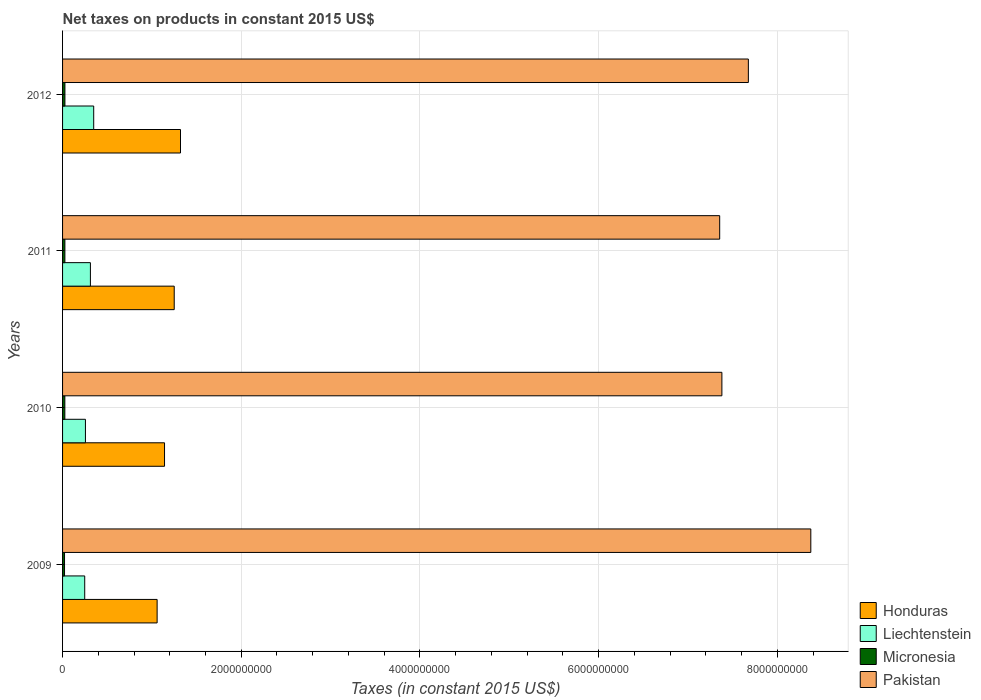How many different coloured bars are there?
Keep it short and to the point. 4. How many groups of bars are there?
Your response must be concise. 4. Are the number of bars on each tick of the Y-axis equal?
Provide a short and direct response. Yes. How many bars are there on the 3rd tick from the bottom?
Offer a very short reply. 4. What is the net taxes on products in Micronesia in 2012?
Offer a very short reply. 2.63e+07. Across all years, what is the maximum net taxes on products in Pakistan?
Make the answer very short. 8.38e+09. Across all years, what is the minimum net taxes on products in Micronesia?
Offer a very short reply. 2.20e+07. In which year was the net taxes on products in Liechtenstein maximum?
Your response must be concise. 2012. What is the total net taxes on products in Micronesia in the graph?
Offer a very short reply. 9.98e+07. What is the difference between the net taxes on products in Liechtenstein in 2009 and that in 2010?
Provide a succinct answer. -7.97e+06. What is the difference between the net taxes on products in Micronesia in 2009 and the net taxes on products in Honduras in 2012?
Your answer should be compact. -1.30e+09. What is the average net taxes on products in Micronesia per year?
Ensure brevity in your answer.  2.49e+07. In the year 2010, what is the difference between the net taxes on products in Honduras and net taxes on products in Micronesia?
Offer a very short reply. 1.12e+09. In how many years, is the net taxes on products in Liechtenstein greater than 3600000000 US$?
Make the answer very short. 0. What is the ratio of the net taxes on products in Liechtenstein in 2009 to that in 2012?
Give a very brief answer. 0.71. What is the difference between the highest and the second highest net taxes on products in Micronesia?
Keep it short and to the point. 2.83e+05. What is the difference between the highest and the lowest net taxes on products in Honduras?
Provide a short and direct response. 2.62e+08. What does the 4th bar from the top in 2009 represents?
Keep it short and to the point. Honduras. What does the 2nd bar from the bottom in 2010 represents?
Offer a very short reply. Liechtenstein. Is it the case that in every year, the sum of the net taxes on products in Pakistan and net taxes on products in Liechtenstein is greater than the net taxes on products in Honduras?
Give a very brief answer. Yes. How many bars are there?
Give a very brief answer. 16. Does the graph contain any zero values?
Offer a terse response. No. Does the graph contain grids?
Provide a short and direct response. Yes. Where does the legend appear in the graph?
Your answer should be very brief. Bottom right. How are the legend labels stacked?
Your response must be concise. Vertical. What is the title of the graph?
Give a very brief answer. Net taxes on products in constant 2015 US$. What is the label or title of the X-axis?
Offer a terse response. Taxes (in constant 2015 US$). What is the label or title of the Y-axis?
Offer a terse response. Years. What is the Taxes (in constant 2015 US$) in Honduras in 2009?
Provide a succinct answer. 1.06e+09. What is the Taxes (in constant 2015 US$) in Liechtenstein in 2009?
Your response must be concise. 2.48e+08. What is the Taxes (in constant 2015 US$) in Micronesia in 2009?
Your answer should be very brief. 2.20e+07. What is the Taxes (in constant 2015 US$) of Pakistan in 2009?
Provide a succinct answer. 8.38e+09. What is the Taxes (in constant 2015 US$) of Honduras in 2010?
Offer a terse response. 1.14e+09. What is the Taxes (in constant 2015 US$) of Liechtenstein in 2010?
Provide a succinct answer. 2.56e+08. What is the Taxes (in constant 2015 US$) of Micronesia in 2010?
Your answer should be very brief. 2.54e+07. What is the Taxes (in constant 2015 US$) of Pakistan in 2010?
Ensure brevity in your answer.  7.38e+09. What is the Taxes (in constant 2015 US$) in Honduras in 2011?
Provide a succinct answer. 1.25e+09. What is the Taxes (in constant 2015 US$) in Liechtenstein in 2011?
Keep it short and to the point. 3.12e+08. What is the Taxes (in constant 2015 US$) in Micronesia in 2011?
Keep it short and to the point. 2.60e+07. What is the Taxes (in constant 2015 US$) of Pakistan in 2011?
Give a very brief answer. 7.36e+09. What is the Taxes (in constant 2015 US$) of Honduras in 2012?
Ensure brevity in your answer.  1.32e+09. What is the Taxes (in constant 2015 US$) of Liechtenstein in 2012?
Give a very brief answer. 3.49e+08. What is the Taxes (in constant 2015 US$) in Micronesia in 2012?
Your answer should be very brief. 2.63e+07. What is the Taxes (in constant 2015 US$) in Pakistan in 2012?
Provide a short and direct response. 7.68e+09. Across all years, what is the maximum Taxes (in constant 2015 US$) of Honduras?
Offer a very short reply. 1.32e+09. Across all years, what is the maximum Taxes (in constant 2015 US$) of Liechtenstein?
Your answer should be very brief. 3.49e+08. Across all years, what is the maximum Taxes (in constant 2015 US$) of Micronesia?
Make the answer very short. 2.63e+07. Across all years, what is the maximum Taxes (in constant 2015 US$) of Pakistan?
Give a very brief answer. 8.38e+09. Across all years, what is the minimum Taxes (in constant 2015 US$) in Honduras?
Keep it short and to the point. 1.06e+09. Across all years, what is the minimum Taxes (in constant 2015 US$) of Liechtenstein?
Your answer should be compact. 2.48e+08. Across all years, what is the minimum Taxes (in constant 2015 US$) of Micronesia?
Keep it short and to the point. 2.20e+07. Across all years, what is the minimum Taxes (in constant 2015 US$) in Pakistan?
Provide a succinct answer. 7.36e+09. What is the total Taxes (in constant 2015 US$) of Honduras in the graph?
Your response must be concise. 4.77e+09. What is the total Taxes (in constant 2015 US$) in Liechtenstein in the graph?
Provide a succinct answer. 1.16e+09. What is the total Taxes (in constant 2015 US$) of Micronesia in the graph?
Offer a terse response. 9.98e+07. What is the total Taxes (in constant 2015 US$) in Pakistan in the graph?
Your response must be concise. 3.08e+1. What is the difference between the Taxes (in constant 2015 US$) in Honduras in 2009 and that in 2010?
Offer a very short reply. -8.28e+07. What is the difference between the Taxes (in constant 2015 US$) in Liechtenstein in 2009 and that in 2010?
Offer a terse response. -7.97e+06. What is the difference between the Taxes (in constant 2015 US$) in Micronesia in 2009 and that in 2010?
Make the answer very short. -3.41e+06. What is the difference between the Taxes (in constant 2015 US$) in Pakistan in 2009 and that in 2010?
Ensure brevity in your answer.  9.95e+08. What is the difference between the Taxes (in constant 2015 US$) of Honduras in 2009 and that in 2011?
Your answer should be compact. -1.91e+08. What is the difference between the Taxes (in constant 2015 US$) of Liechtenstein in 2009 and that in 2011?
Keep it short and to the point. -6.38e+07. What is the difference between the Taxes (in constant 2015 US$) in Micronesia in 2009 and that in 2011?
Ensure brevity in your answer.  -4.00e+06. What is the difference between the Taxes (in constant 2015 US$) in Pakistan in 2009 and that in 2011?
Your answer should be compact. 1.02e+09. What is the difference between the Taxes (in constant 2015 US$) of Honduras in 2009 and that in 2012?
Make the answer very short. -2.62e+08. What is the difference between the Taxes (in constant 2015 US$) in Liechtenstein in 2009 and that in 2012?
Give a very brief answer. -1.01e+08. What is the difference between the Taxes (in constant 2015 US$) in Micronesia in 2009 and that in 2012?
Make the answer very short. -4.28e+06. What is the difference between the Taxes (in constant 2015 US$) of Pakistan in 2009 and that in 2012?
Provide a short and direct response. 6.99e+08. What is the difference between the Taxes (in constant 2015 US$) of Honduras in 2010 and that in 2011?
Your answer should be compact. -1.08e+08. What is the difference between the Taxes (in constant 2015 US$) in Liechtenstein in 2010 and that in 2011?
Keep it short and to the point. -5.58e+07. What is the difference between the Taxes (in constant 2015 US$) in Micronesia in 2010 and that in 2011?
Make the answer very short. -5.89e+05. What is the difference between the Taxes (in constant 2015 US$) of Pakistan in 2010 and that in 2011?
Provide a short and direct response. 2.47e+07. What is the difference between the Taxes (in constant 2015 US$) of Honduras in 2010 and that in 2012?
Your answer should be compact. -1.79e+08. What is the difference between the Taxes (in constant 2015 US$) in Liechtenstein in 2010 and that in 2012?
Give a very brief answer. -9.26e+07. What is the difference between the Taxes (in constant 2015 US$) of Micronesia in 2010 and that in 2012?
Offer a terse response. -8.73e+05. What is the difference between the Taxes (in constant 2015 US$) in Pakistan in 2010 and that in 2012?
Give a very brief answer. -2.96e+08. What is the difference between the Taxes (in constant 2015 US$) of Honduras in 2011 and that in 2012?
Provide a succinct answer. -7.04e+07. What is the difference between the Taxes (in constant 2015 US$) of Liechtenstein in 2011 and that in 2012?
Keep it short and to the point. -3.68e+07. What is the difference between the Taxes (in constant 2015 US$) of Micronesia in 2011 and that in 2012?
Offer a very short reply. -2.83e+05. What is the difference between the Taxes (in constant 2015 US$) of Pakistan in 2011 and that in 2012?
Keep it short and to the point. -3.21e+08. What is the difference between the Taxes (in constant 2015 US$) of Honduras in 2009 and the Taxes (in constant 2015 US$) of Liechtenstein in 2010?
Provide a short and direct response. 8.03e+08. What is the difference between the Taxes (in constant 2015 US$) of Honduras in 2009 and the Taxes (in constant 2015 US$) of Micronesia in 2010?
Offer a very short reply. 1.03e+09. What is the difference between the Taxes (in constant 2015 US$) in Honduras in 2009 and the Taxes (in constant 2015 US$) in Pakistan in 2010?
Your response must be concise. -6.32e+09. What is the difference between the Taxes (in constant 2015 US$) in Liechtenstein in 2009 and the Taxes (in constant 2015 US$) in Micronesia in 2010?
Your answer should be compact. 2.23e+08. What is the difference between the Taxes (in constant 2015 US$) of Liechtenstein in 2009 and the Taxes (in constant 2015 US$) of Pakistan in 2010?
Keep it short and to the point. -7.13e+09. What is the difference between the Taxes (in constant 2015 US$) in Micronesia in 2009 and the Taxes (in constant 2015 US$) in Pakistan in 2010?
Your answer should be compact. -7.36e+09. What is the difference between the Taxes (in constant 2015 US$) of Honduras in 2009 and the Taxes (in constant 2015 US$) of Liechtenstein in 2011?
Ensure brevity in your answer.  7.47e+08. What is the difference between the Taxes (in constant 2015 US$) in Honduras in 2009 and the Taxes (in constant 2015 US$) in Micronesia in 2011?
Your answer should be compact. 1.03e+09. What is the difference between the Taxes (in constant 2015 US$) in Honduras in 2009 and the Taxes (in constant 2015 US$) in Pakistan in 2011?
Keep it short and to the point. -6.30e+09. What is the difference between the Taxes (in constant 2015 US$) of Liechtenstein in 2009 and the Taxes (in constant 2015 US$) of Micronesia in 2011?
Provide a succinct answer. 2.22e+08. What is the difference between the Taxes (in constant 2015 US$) of Liechtenstein in 2009 and the Taxes (in constant 2015 US$) of Pakistan in 2011?
Your answer should be very brief. -7.11e+09. What is the difference between the Taxes (in constant 2015 US$) in Micronesia in 2009 and the Taxes (in constant 2015 US$) in Pakistan in 2011?
Ensure brevity in your answer.  -7.33e+09. What is the difference between the Taxes (in constant 2015 US$) in Honduras in 2009 and the Taxes (in constant 2015 US$) in Liechtenstein in 2012?
Your response must be concise. 7.10e+08. What is the difference between the Taxes (in constant 2015 US$) of Honduras in 2009 and the Taxes (in constant 2015 US$) of Micronesia in 2012?
Keep it short and to the point. 1.03e+09. What is the difference between the Taxes (in constant 2015 US$) in Honduras in 2009 and the Taxes (in constant 2015 US$) in Pakistan in 2012?
Provide a succinct answer. -6.62e+09. What is the difference between the Taxes (in constant 2015 US$) in Liechtenstein in 2009 and the Taxes (in constant 2015 US$) in Micronesia in 2012?
Make the answer very short. 2.22e+08. What is the difference between the Taxes (in constant 2015 US$) in Liechtenstein in 2009 and the Taxes (in constant 2015 US$) in Pakistan in 2012?
Provide a succinct answer. -7.43e+09. What is the difference between the Taxes (in constant 2015 US$) of Micronesia in 2009 and the Taxes (in constant 2015 US$) of Pakistan in 2012?
Give a very brief answer. -7.65e+09. What is the difference between the Taxes (in constant 2015 US$) in Honduras in 2010 and the Taxes (in constant 2015 US$) in Liechtenstein in 2011?
Your response must be concise. 8.30e+08. What is the difference between the Taxes (in constant 2015 US$) of Honduras in 2010 and the Taxes (in constant 2015 US$) of Micronesia in 2011?
Keep it short and to the point. 1.12e+09. What is the difference between the Taxes (in constant 2015 US$) in Honduras in 2010 and the Taxes (in constant 2015 US$) in Pakistan in 2011?
Keep it short and to the point. -6.21e+09. What is the difference between the Taxes (in constant 2015 US$) of Liechtenstein in 2010 and the Taxes (in constant 2015 US$) of Micronesia in 2011?
Make the answer very short. 2.30e+08. What is the difference between the Taxes (in constant 2015 US$) in Liechtenstein in 2010 and the Taxes (in constant 2015 US$) in Pakistan in 2011?
Provide a short and direct response. -7.10e+09. What is the difference between the Taxes (in constant 2015 US$) in Micronesia in 2010 and the Taxes (in constant 2015 US$) in Pakistan in 2011?
Offer a terse response. -7.33e+09. What is the difference between the Taxes (in constant 2015 US$) of Honduras in 2010 and the Taxes (in constant 2015 US$) of Liechtenstein in 2012?
Provide a succinct answer. 7.93e+08. What is the difference between the Taxes (in constant 2015 US$) of Honduras in 2010 and the Taxes (in constant 2015 US$) of Micronesia in 2012?
Provide a succinct answer. 1.11e+09. What is the difference between the Taxes (in constant 2015 US$) of Honduras in 2010 and the Taxes (in constant 2015 US$) of Pakistan in 2012?
Your answer should be very brief. -6.53e+09. What is the difference between the Taxes (in constant 2015 US$) in Liechtenstein in 2010 and the Taxes (in constant 2015 US$) in Micronesia in 2012?
Your answer should be very brief. 2.30e+08. What is the difference between the Taxes (in constant 2015 US$) in Liechtenstein in 2010 and the Taxes (in constant 2015 US$) in Pakistan in 2012?
Provide a succinct answer. -7.42e+09. What is the difference between the Taxes (in constant 2015 US$) in Micronesia in 2010 and the Taxes (in constant 2015 US$) in Pakistan in 2012?
Provide a succinct answer. -7.65e+09. What is the difference between the Taxes (in constant 2015 US$) of Honduras in 2011 and the Taxes (in constant 2015 US$) of Liechtenstein in 2012?
Your answer should be compact. 9.01e+08. What is the difference between the Taxes (in constant 2015 US$) in Honduras in 2011 and the Taxes (in constant 2015 US$) in Micronesia in 2012?
Ensure brevity in your answer.  1.22e+09. What is the difference between the Taxes (in constant 2015 US$) in Honduras in 2011 and the Taxes (in constant 2015 US$) in Pakistan in 2012?
Provide a short and direct response. -6.43e+09. What is the difference between the Taxes (in constant 2015 US$) of Liechtenstein in 2011 and the Taxes (in constant 2015 US$) of Micronesia in 2012?
Provide a short and direct response. 2.85e+08. What is the difference between the Taxes (in constant 2015 US$) of Liechtenstein in 2011 and the Taxes (in constant 2015 US$) of Pakistan in 2012?
Give a very brief answer. -7.36e+09. What is the difference between the Taxes (in constant 2015 US$) in Micronesia in 2011 and the Taxes (in constant 2015 US$) in Pakistan in 2012?
Offer a very short reply. -7.65e+09. What is the average Taxes (in constant 2015 US$) of Honduras per year?
Provide a succinct answer. 1.19e+09. What is the average Taxes (in constant 2015 US$) of Liechtenstein per year?
Make the answer very short. 2.91e+08. What is the average Taxes (in constant 2015 US$) of Micronesia per year?
Ensure brevity in your answer.  2.49e+07. What is the average Taxes (in constant 2015 US$) of Pakistan per year?
Provide a succinct answer. 7.70e+09. In the year 2009, what is the difference between the Taxes (in constant 2015 US$) of Honduras and Taxes (in constant 2015 US$) of Liechtenstein?
Your answer should be compact. 8.11e+08. In the year 2009, what is the difference between the Taxes (in constant 2015 US$) of Honduras and Taxes (in constant 2015 US$) of Micronesia?
Offer a very short reply. 1.04e+09. In the year 2009, what is the difference between the Taxes (in constant 2015 US$) in Honduras and Taxes (in constant 2015 US$) in Pakistan?
Give a very brief answer. -7.32e+09. In the year 2009, what is the difference between the Taxes (in constant 2015 US$) in Liechtenstein and Taxes (in constant 2015 US$) in Micronesia?
Provide a succinct answer. 2.26e+08. In the year 2009, what is the difference between the Taxes (in constant 2015 US$) in Liechtenstein and Taxes (in constant 2015 US$) in Pakistan?
Provide a succinct answer. -8.13e+09. In the year 2009, what is the difference between the Taxes (in constant 2015 US$) in Micronesia and Taxes (in constant 2015 US$) in Pakistan?
Ensure brevity in your answer.  -8.35e+09. In the year 2010, what is the difference between the Taxes (in constant 2015 US$) of Honduras and Taxes (in constant 2015 US$) of Liechtenstein?
Give a very brief answer. 8.85e+08. In the year 2010, what is the difference between the Taxes (in constant 2015 US$) in Honduras and Taxes (in constant 2015 US$) in Micronesia?
Provide a short and direct response. 1.12e+09. In the year 2010, what is the difference between the Taxes (in constant 2015 US$) of Honduras and Taxes (in constant 2015 US$) of Pakistan?
Provide a short and direct response. -6.24e+09. In the year 2010, what is the difference between the Taxes (in constant 2015 US$) of Liechtenstein and Taxes (in constant 2015 US$) of Micronesia?
Your response must be concise. 2.30e+08. In the year 2010, what is the difference between the Taxes (in constant 2015 US$) of Liechtenstein and Taxes (in constant 2015 US$) of Pakistan?
Provide a succinct answer. -7.12e+09. In the year 2010, what is the difference between the Taxes (in constant 2015 US$) in Micronesia and Taxes (in constant 2015 US$) in Pakistan?
Provide a succinct answer. -7.35e+09. In the year 2011, what is the difference between the Taxes (in constant 2015 US$) of Honduras and Taxes (in constant 2015 US$) of Liechtenstein?
Offer a very short reply. 9.38e+08. In the year 2011, what is the difference between the Taxes (in constant 2015 US$) of Honduras and Taxes (in constant 2015 US$) of Micronesia?
Your answer should be very brief. 1.22e+09. In the year 2011, what is the difference between the Taxes (in constant 2015 US$) of Honduras and Taxes (in constant 2015 US$) of Pakistan?
Offer a very short reply. -6.11e+09. In the year 2011, what is the difference between the Taxes (in constant 2015 US$) in Liechtenstein and Taxes (in constant 2015 US$) in Micronesia?
Offer a terse response. 2.86e+08. In the year 2011, what is the difference between the Taxes (in constant 2015 US$) of Liechtenstein and Taxes (in constant 2015 US$) of Pakistan?
Your answer should be compact. -7.04e+09. In the year 2011, what is the difference between the Taxes (in constant 2015 US$) in Micronesia and Taxes (in constant 2015 US$) in Pakistan?
Your answer should be very brief. -7.33e+09. In the year 2012, what is the difference between the Taxes (in constant 2015 US$) of Honduras and Taxes (in constant 2015 US$) of Liechtenstein?
Your response must be concise. 9.72e+08. In the year 2012, what is the difference between the Taxes (in constant 2015 US$) in Honduras and Taxes (in constant 2015 US$) in Micronesia?
Provide a succinct answer. 1.29e+09. In the year 2012, what is the difference between the Taxes (in constant 2015 US$) in Honduras and Taxes (in constant 2015 US$) in Pakistan?
Offer a terse response. -6.36e+09. In the year 2012, what is the difference between the Taxes (in constant 2015 US$) in Liechtenstein and Taxes (in constant 2015 US$) in Micronesia?
Your response must be concise. 3.22e+08. In the year 2012, what is the difference between the Taxes (in constant 2015 US$) of Liechtenstein and Taxes (in constant 2015 US$) of Pakistan?
Your response must be concise. -7.33e+09. In the year 2012, what is the difference between the Taxes (in constant 2015 US$) of Micronesia and Taxes (in constant 2015 US$) of Pakistan?
Your answer should be compact. -7.65e+09. What is the ratio of the Taxes (in constant 2015 US$) of Honduras in 2009 to that in 2010?
Offer a very short reply. 0.93. What is the ratio of the Taxes (in constant 2015 US$) of Liechtenstein in 2009 to that in 2010?
Give a very brief answer. 0.97. What is the ratio of the Taxes (in constant 2015 US$) in Micronesia in 2009 to that in 2010?
Your answer should be compact. 0.87. What is the ratio of the Taxes (in constant 2015 US$) in Pakistan in 2009 to that in 2010?
Offer a terse response. 1.13. What is the ratio of the Taxes (in constant 2015 US$) of Honduras in 2009 to that in 2011?
Provide a short and direct response. 0.85. What is the ratio of the Taxes (in constant 2015 US$) of Liechtenstein in 2009 to that in 2011?
Make the answer very short. 0.8. What is the ratio of the Taxes (in constant 2015 US$) in Micronesia in 2009 to that in 2011?
Your response must be concise. 0.85. What is the ratio of the Taxes (in constant 2015 US$) of Pakistan in 2009 to that in 2011?
Provide a short and direct response. 1.14. What is the ratio of the Taxes (in constant 2015 US$) in Honduras in 2009 to that in 2012?
Provide a short and direct response. 0.8. What is the ratio of the Taxes (in constant 2015 US$) of Liechtenstein in 2009 to that in 2012?
Ensure brevity in your answer.  0.71. What is the ratio of the Taxes (in constant 2015 US$) of Micronesia in 2009 to that in 2012?
Your response must be concise. 0.84. What is the ratio of the Taxes (in constant 2015 US$) of Pakistan in 2009 to that in 2012?
Your response must be concise. 1.09. What is the ratio of the Taxes (in constant 2015 US$) of Honduras in 2010 to that in 2011?
Offer a terse response. 0.91. What is the ratio of the Taxes (in constant 2015 US$) of Liechtenstein in 2010 to that in 2011?
Your answer should be compact. 0.82. What is the ratio of the Taxes (in constant 2015 US$) of Micronesia in 2010 to that in 2011?
Make the answer very short. 0.98. What is the ratio of the Taxes (in constant 2015 US$) in Pakistan in 2010 to that in 2011?
Make the answer very short. 1. What is the ratio of the Taxes (in constant 2015 US$) of Honduras in 2010 to that in 2012?
Your answer should be very brief. 0.86. What is the ratio of the Taxes (in constant 2015 US$) in Liechtenstein in 2010 to that in 2012?
Your answer should be compact. 0.73. What is the ratio of the Taxes (in constant 2015 US$) of Micronesia in 2010 to that in 2012?
Offer a terse response. 0.97. What is the ratio of the Taxes (in constant 2015 US$) of Pakistan in 2010 to that in 2012?
Offer a very short reply. 0.96. What is the ratio of the Taxes (in constant 2015 US$) in Honduras in 2011 to that in 2012?
Provide a short and direct response. 0.95. What is the ratio of the Taxes (in constant 2015 US$) in Liechtenstein in 2011 to that in 2012?
Give a very brief answer. 0.89. What is the ratio of the Taxes (in constant 2015 US$) in Pakistan in 2011 to that in 2012?
Offer a very short reply. 0.96. What is the difference between the highest and the second highest Taxes (in constant 2015 US$) of Honduras?
Ensure brevity in your answer.  7.04e+07. What is the difference between the highest and the second highest Taxes (in constant 2015 US$) in Liechtenstein?
Make the answer very short. 3.68e+07. What is the difference between the highest and the second highest Taxes (in constant 2015 US$) in Micronesia?
Your answer should be compact. 2.83e+05. What is the difference between the highest and the second highest Taxes (in constant 2015 US$) in Pakistan?
Provide a succinct answer. 6.99e+08. What is the difference between the highest and the lowest Taxes (in constant 2015 US$) of Honduras?
Your answer should be compact. 2.62e+08. What is the difference between the highest and the lowest Taxes (in constant 2015 US$) of Liechtenstein?
Keep it short and to the point. 1.01e+08. What is the difference between the highest and the lowest Taxes (in constant 2015 US$) of Micronesia?
Give a very brief answer. 4.28e+06. What is the difference between the highest and the lowest Taxes (in constant 2015 US$) in Pakistan?
Your response must be concise. 1.02e+09. 